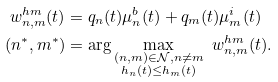<formula> <loc_0><loc_0><loc_500><loc_500>w _ { n , m } ^ { h m } ( t ) & = q _ { n } ( t ) \mu _ { n } ^ { b } ( t ) + q _ { m } ( t ) \mu _ { m } ^ { i } ( t ) \\ ( n ^ { * } , m ^ { * } ) & = \arg \max _ { \substack { ( n , m ) \in \mathcal { N } , n \neq m \\ h _ { n } ( t ) \leq h _ { m } ( t ) } } \ w ^ { h m } _ { n , m } ( t ) .</formula> 